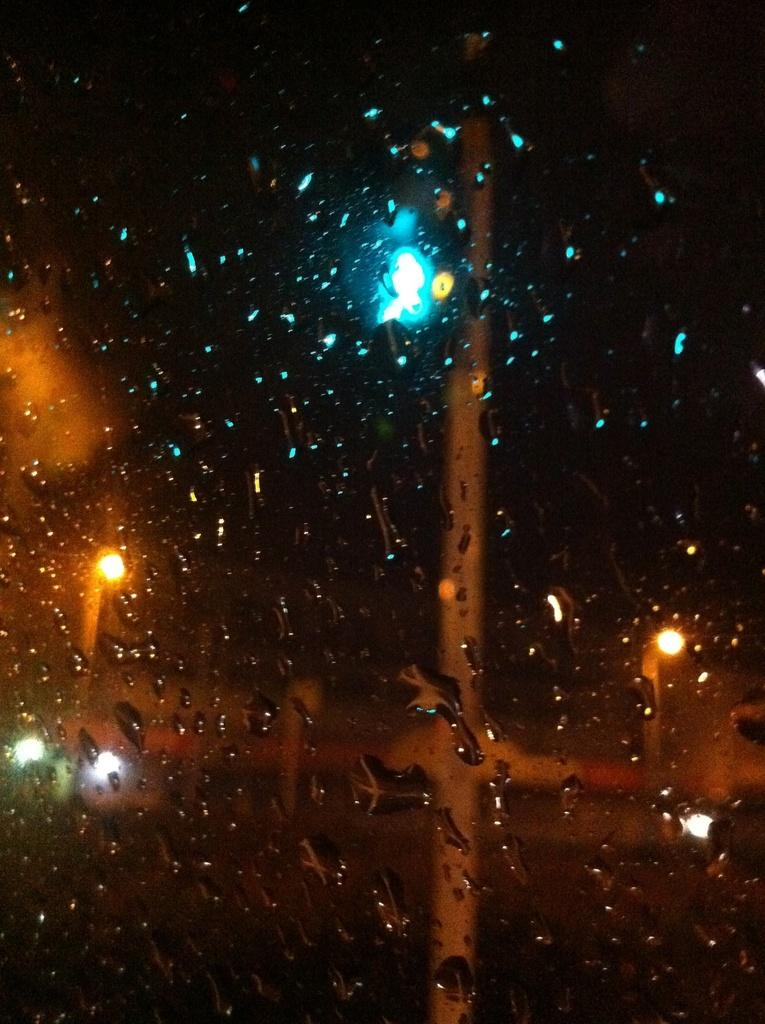What object is present in the image that is typically used for holding liquids? There is a glass in the image. What can be observed on the surface of the glass? There are water droplets on the glass. What is located in the middle of the image? There are lights in the middle of the image. What type of joke is being told by the yak in the image? There is no yak present in the image, so it is not possible to determine if a joke is being told or by whom. 